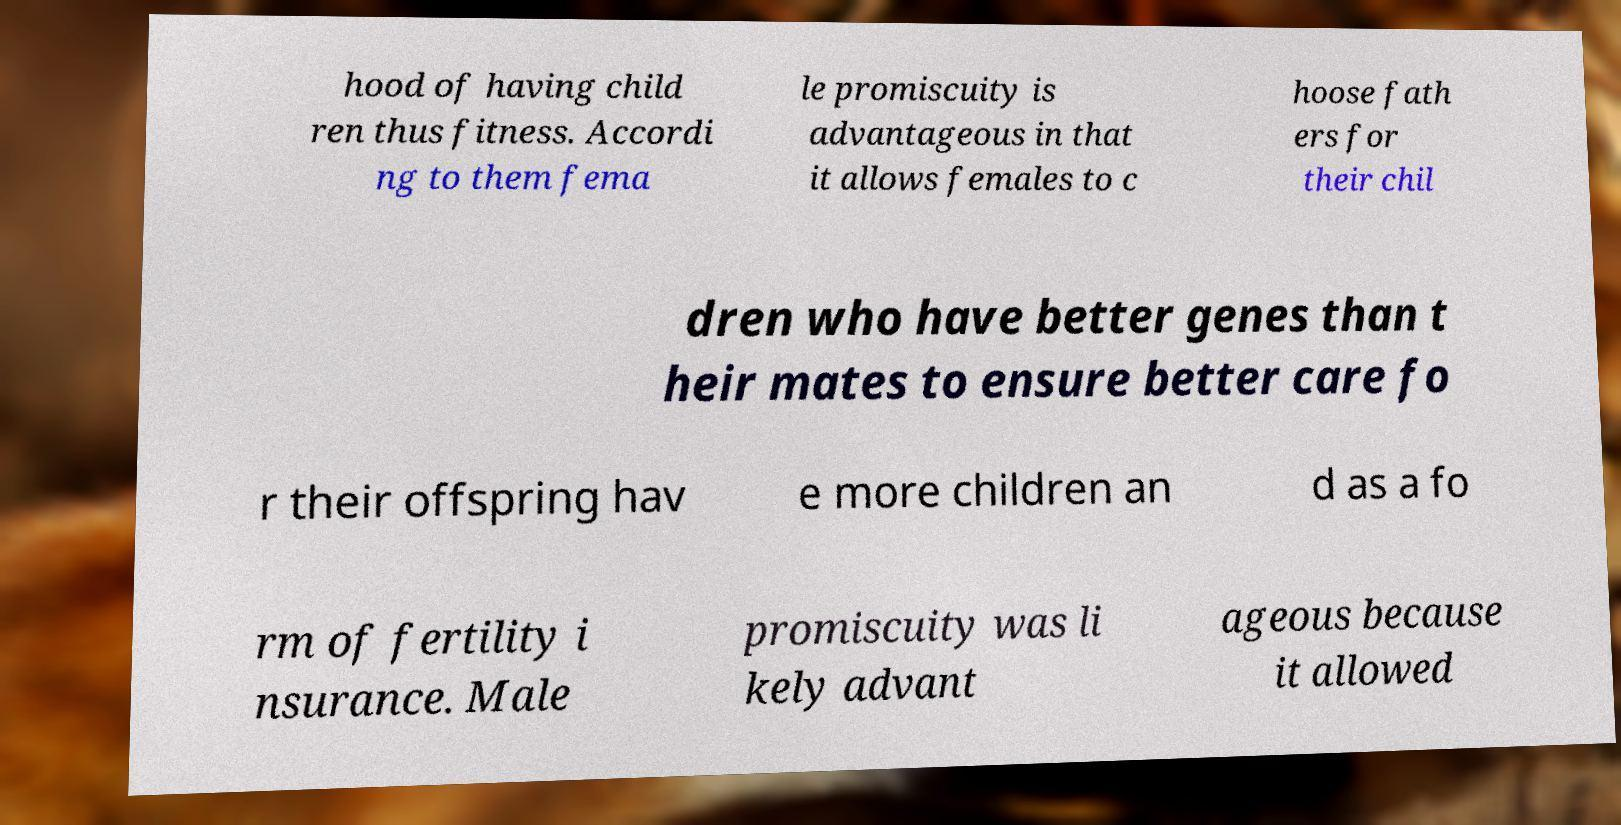Can you read and provide the text displayed in the image?This photo seems to have some interesting text. Can you extract and type it out for me? hood of having child ren thus fitness. Accordi ng to them fema le promiscuity is advantageous in that it allows females to c hoose fath ers for their chil dren who have better genes than t heir mates to ensure better care fo r their offspring hav e more children an d as a fo rm of fertility i nsurance. Male promiscuity was li kely advant ageous because it allowed 